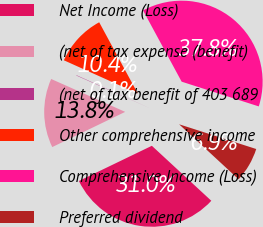<chart> <loc_0><loc_0><loc_500><loc_500><pie_chart><fcel>Net Income (Loss)<fcel>(net of tax expense (benefit)<fcel>(net of tax benefit of 403 689<fcel>Other comprehensive income<fcel>Comprehensive Income (Loss)<fcel>Preferred dividend<nl><fcel>30.97%<fcel>13.81%<fcel>0.07%<fcel>10.38%<fcel>37.84%<fcel>6.94%<nl></chart> 